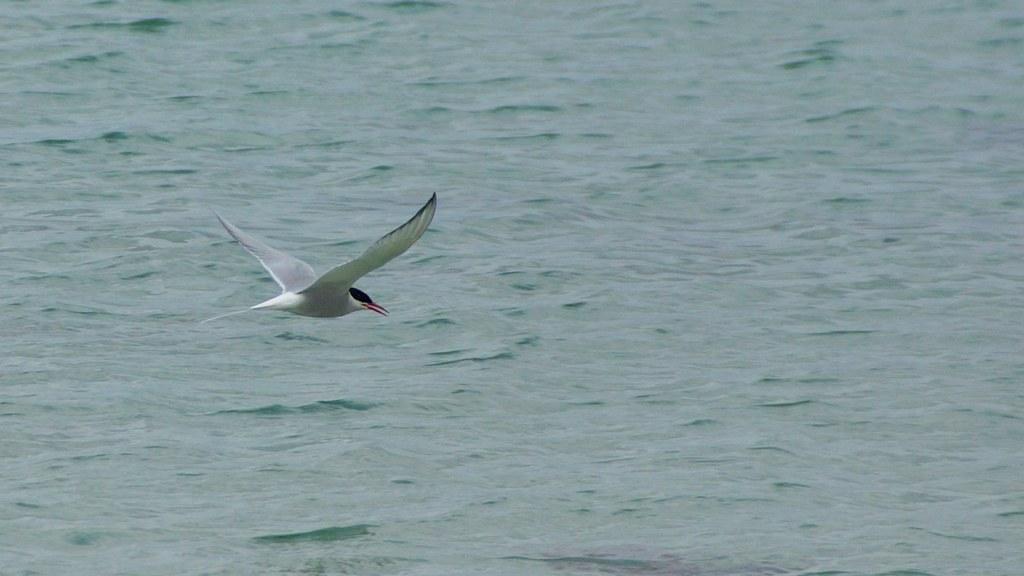In one or two sentences, can you explain what this image depicts? There is a bird flying in the air as we can see in the middle of this image, and there is a Sea in the background. 